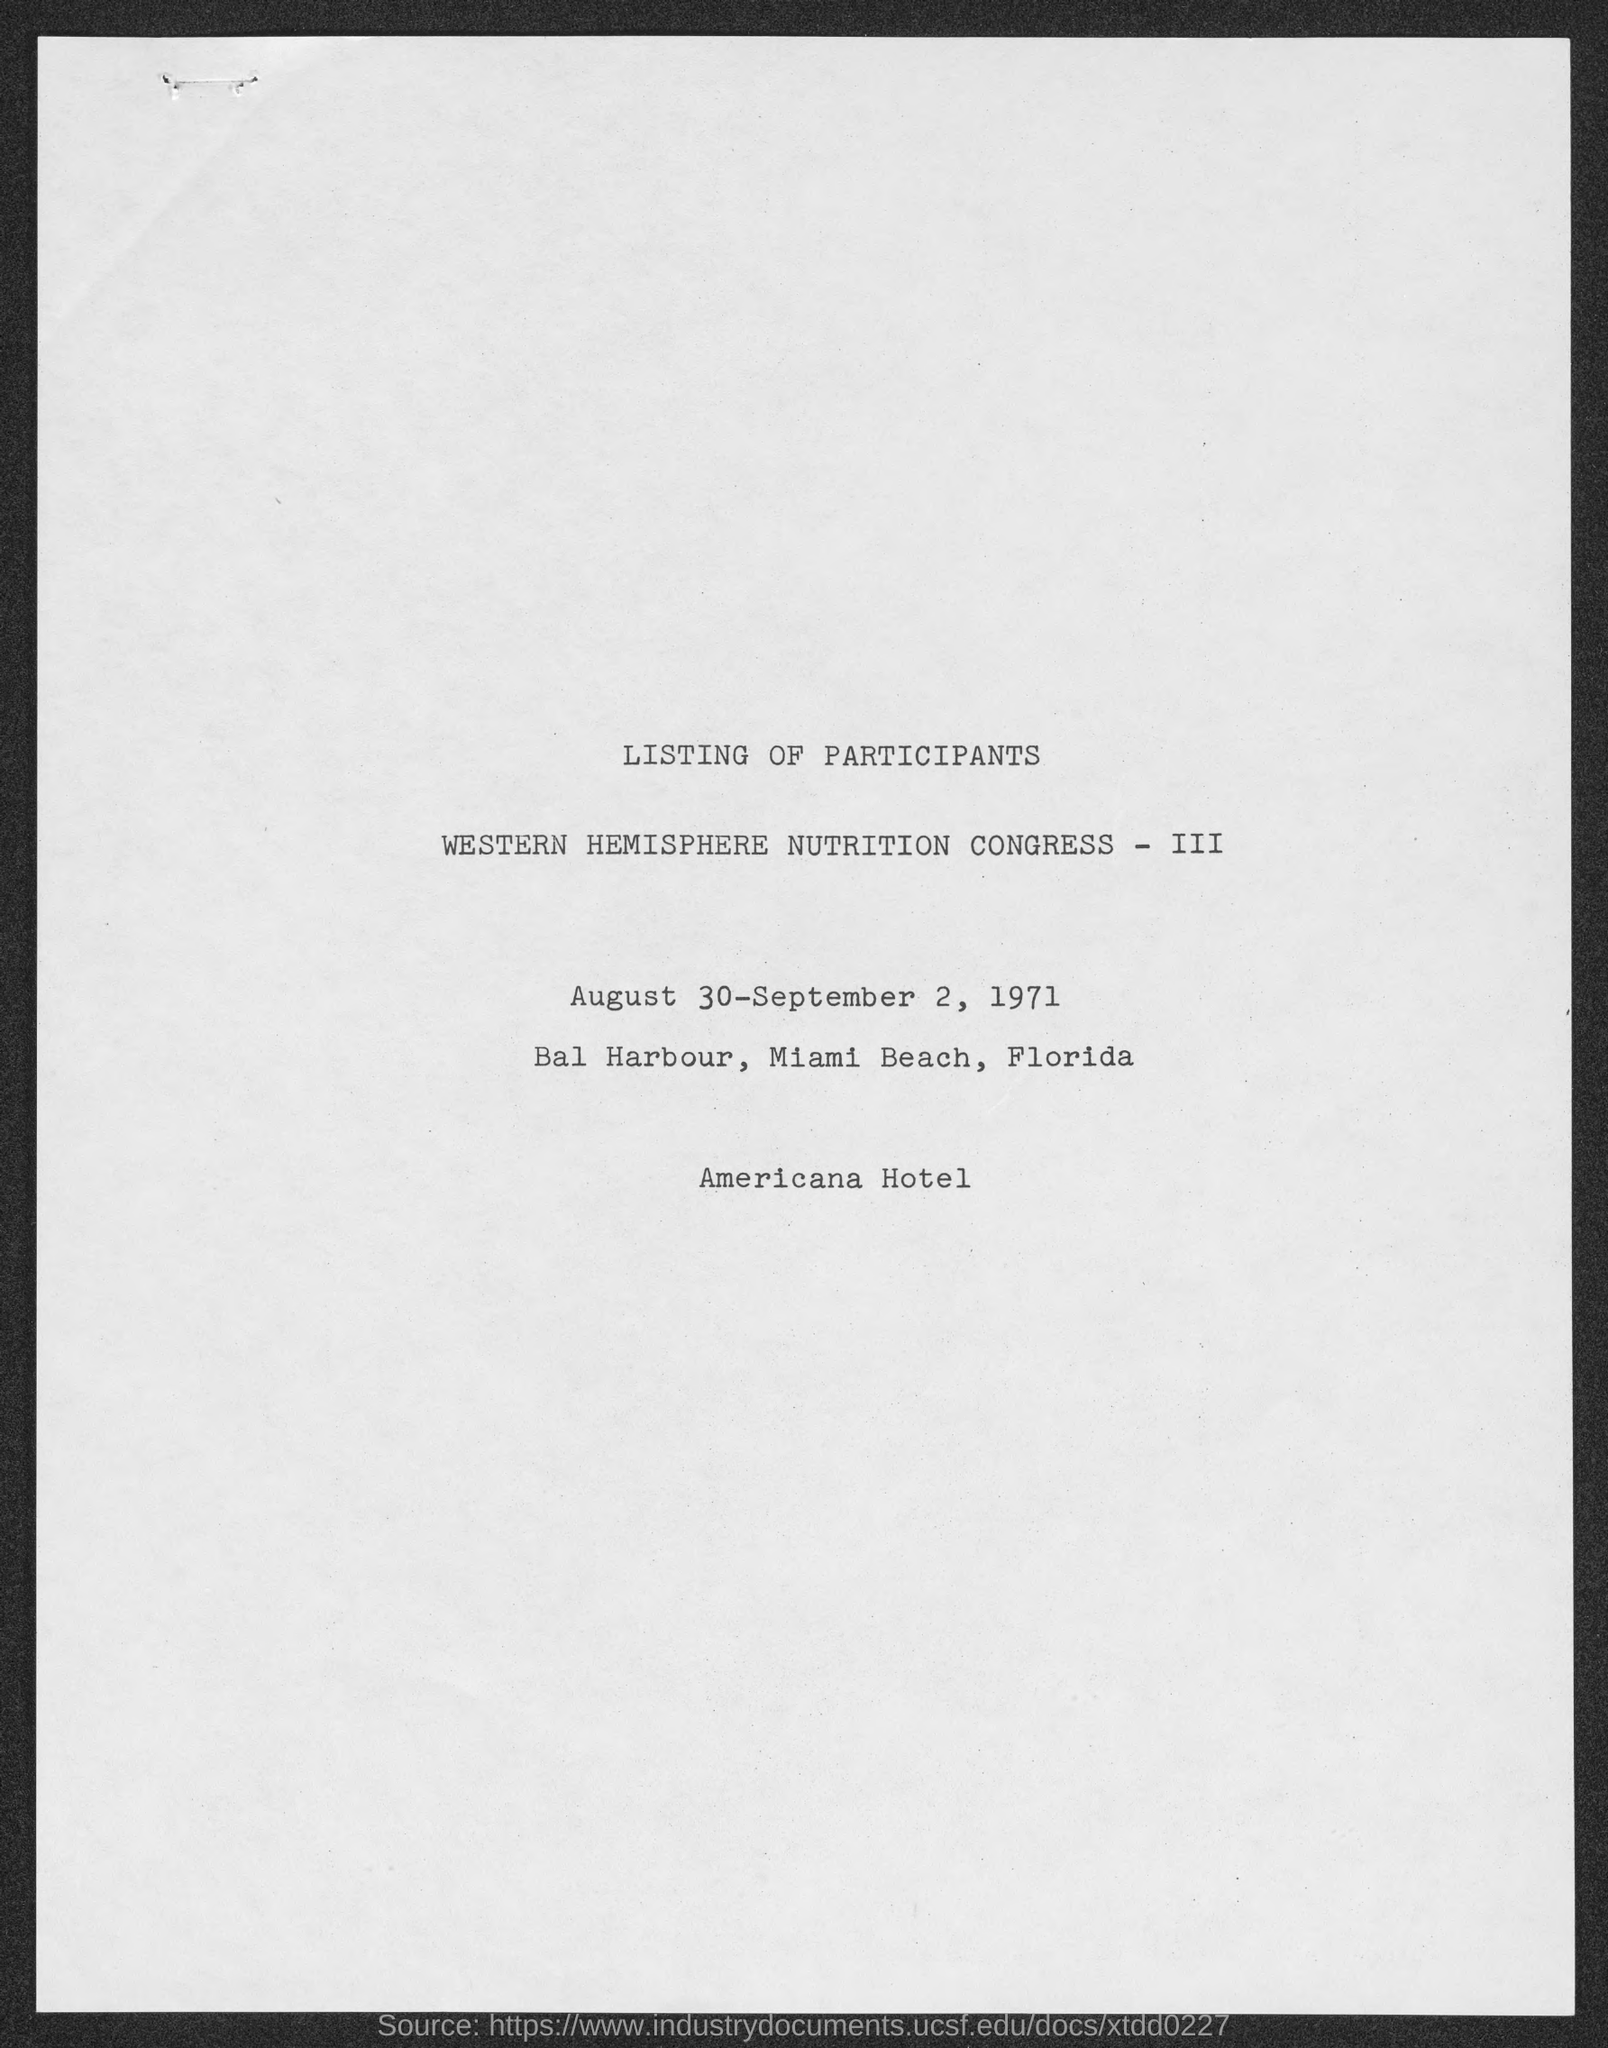Mention a couple of crucial points in this snapshot. The Western Hemisphere Nutrition Congress - III will be held at Bal Harbour, Miami Beach, Florida. The name of the hotel mentioned in the last line is "Americana Hotel". The event name mentioned in the second line is "Western Hemisphere Nutrition Congress - III. The listing of participants is mentioned in the first line. The Western Hemisphere Nutrition Congress - III will take place on August 30-September 2, 1971. 